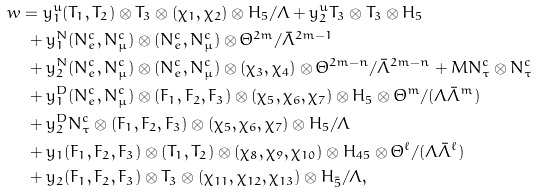<formula> <loc_0><loc_0><loc_500><loc_500>w & = y _ { 1 } ^ { u } ( T _ { 1 } , T _ { 2 } ) \otimes T _ { 3 } \otimes ( \chi _ { 1 } , \chi _ { 2 } ) \otimes H _ { 5 } / \Lambda + y _ { 2 } ^ { u } T _ { 3 } \otimes T _ { 3 } \otimes H _ { 5 } \\ & \ + y _ { 1 } ^ { N } ( N _ { e } ^ { c } , N _ { \mu } ^ { c } ) \otimes ( N _ { e } ^ { c } , N _ { \mu } ^ { c } ) \otimes \Theta ^ { 2 m } / \bar { \Lambda } ^ { 2 m - 1 } \\ & \ + y _ { 2 } ^ { N } ( N _ { e } ^ { c } , N _ { \mu } ^ { c } ) \otimes ( N _ { e } ^ { c } , N _ { \mu } ^ { c } ) \otimes ( \chi _ { 3 } , \chi _ { 4 } ) \otimes \Theta ^ { 2 m - n } / \bar { \Lambda } ^ { 2 m - n } + M N _ { \tau } ^ { c } \otimes N _ { \tau } ^ { c } \\ & \ + y _ { 1 } ^ { D } ( N _ { e } ^ { c } , N _ { \mu } ^ { c } ) \otimes ( F _ { 1 } , F _ { 2 } , F _ { 3 } ) \otimes ( \chi _ { 5 } , \chi _ { 6 } , \chi _ { 7 } ) \otimes H _ { 5 } \otimes \Theta ^ { m } / ( \Lambda \bar { \Lambda } ^ { m } ) \\ & \ + y _ { 2 } ^ { D } N _ { \tau } ^ { c } \otimes ( F _ { 1 } , F _ { 2 } , F _ { 3 } ) \otimes ( \chi _ { 5 } , \chi _ { 6 } , \chi _ { 7 } ) \otimes H _ { 5 } / \Lambda \\ & \ + y _ { 1 } ( F _ { 1 } , F _ { 2 } , F _ { 3 } ) \otimes ( T _ { 1 } , T _ { 2 } ) \otimes ( \chi _ { 8 } , \chi _ { 9 } , \chi _ { 1 0 } ) \otimes H _ { 4 5 } \otimes \Theta ^ { \ell } / ( \Lambda \bar { \Lambda } ^ { \ell } ) \\ & \ + y _ { 2 } ( F _ { 1 } , F _ { 2 } , F _ { 3 } ) \otimes T _ { 3 } \otimes ( \chi _ { 1 1 } , \chi _ { 1 2 } , \chi _ { 1 3 } ) \otimes H _ { \bar { 5 } } / \Lambda ,</formula> 